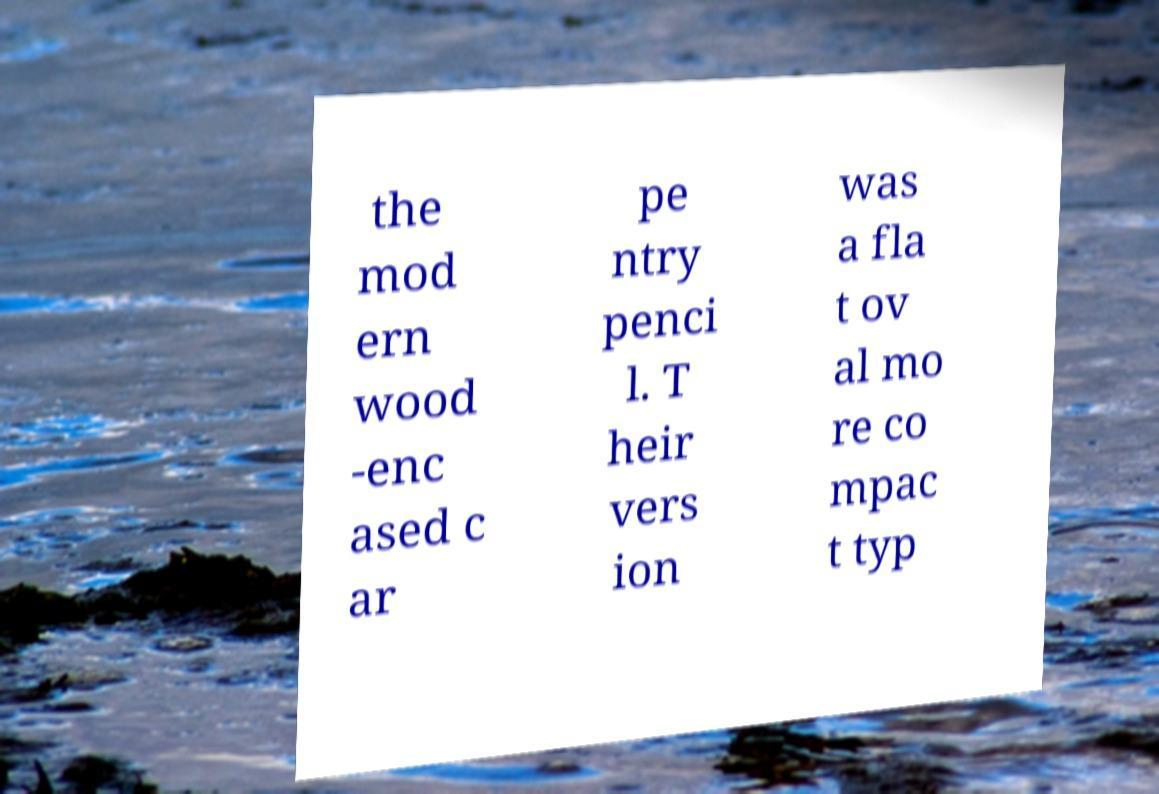Could you assist in decoding the text presented in this image and type it out clearly? the mod ern wood -enc ased c ar pe ntry penci l. T heir vers ion was a fla t ov al mo re co mpac t typ 